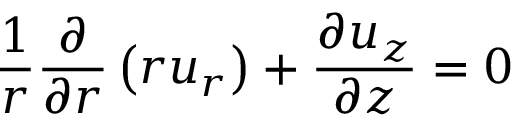Convert formula to latex. <formula><loc_0><loc_0><loc_500><loc_500>\frac { 1 } { r } \frac { \partial } { { \partial } r } \left ( r u _ { r } \right ) + \frac { { \partial } u _ { z } } { { \partial } z } = 0</formula> 